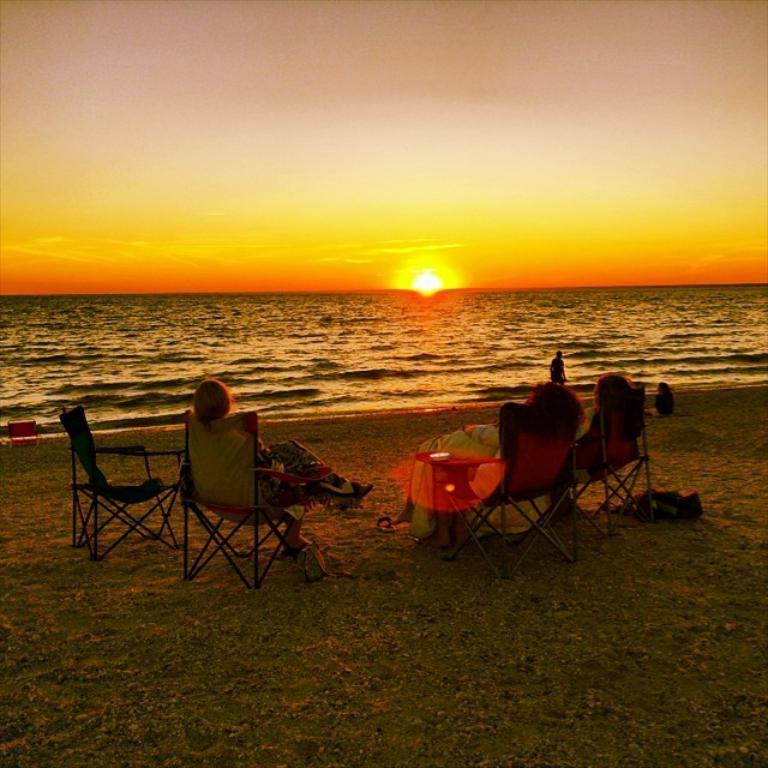How would you summarize this image in a sentence or two? This is the picture of a sea. In this image there are group of people sitting on the chairs and there is a person sitting on the sand and there is a person standing. At the top there is sky and there is a sun. At the bottom there is water and sand. 